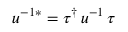Convert formula to latex. <formula><loc_0><loc_0><loc_500><loc_500>u ^ { - 1 * } = \tau ^ { \dagger } \, u ^ { - 1 } \, \tau</formula> 